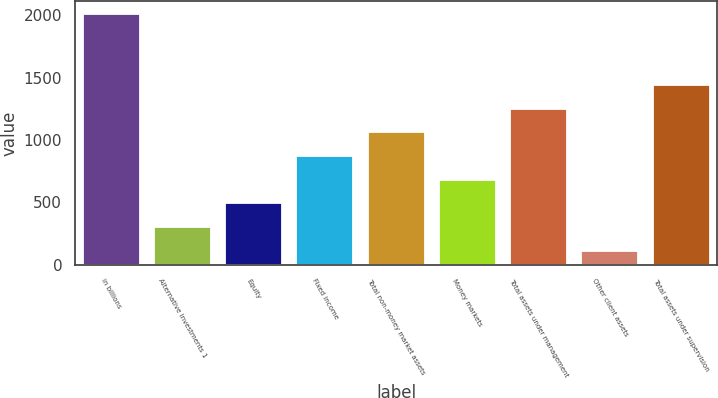<chart> <loc_0><loc_0><loc_500><loc_500><bar_chart><fcel>in billions<fcel>Alternative investments 1<fcel>Equity<fcel>Fixed income<fcel>Total non-money market assets<fcel>Money markets<fcel>Total assets under management<fcel>Other client assets<fcel>Total assets under supervision<nl><fcel>2012<fcel>301.1<fcel>491.2<fcel>871.4<fcel>1061.5<fcel>681.3<fcel>1251.6<fcel>111<fcel>1441.7<nl></chart> 